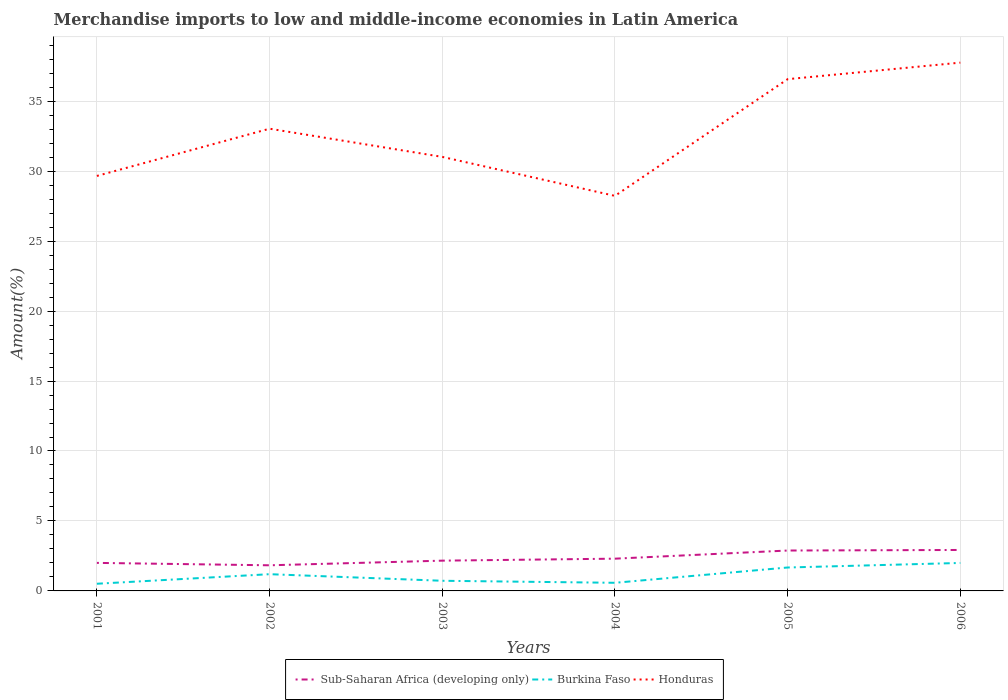Does the line corresponding to Sub-Saharan Africa (developing only) intersect with the line corresponding to Burkina Faso?
Make the answer very short. No. Is the number of lines equal to the number of legend labels?
Offer a very short reply. Yes. Across all years, what is the maximum percentage of amount earned from merchandise imports in Honduras?
Ensure brevity in your answer.  28.23. In which year was the percentage of amount earned from merchandise imports in Honduras maximum?
Your answer should be compact. 2004. What is the total percentage of amount earned from merchandise imports in Burkina Faso in the graph?
Provide a succinct answer. -0.07. What is the difference between the highest and the second highest percentage of amount earned from merchandise imports in Burkina Faso?
Offer a very short reply. 1.49. Is the percentage of amount earned from merchandise imports in Burkina Faso strictly greater than the percentage of amount earned from merchandise imports in Sub-Saharan Africa (developing only) over the years?
Give a very brief answer. Yes. How many lines are there?
Provide a succinct answer. 3. How many years are there in the graph?
Your response must be concise. 6. Are the values on the major ticks of Y-axis written in scientific E-notation?
Your response must be concise. No. Does the graph contain grids?
Provide a short and direct response. Yes. Where does the legend appear in the graph?
Provide a succinct answer. Bottom center. What is the title of the graph?
Provide a short and direct response. Merchandise imports to low and middle-income economies in Latin America. Does "St. Kitts and Nevis" appear as one of the legend labels in the graph?
Your answer should be very brief. No. What is the label or title of the Y-axis?
Keep it short and to the point. Amount(%). What is the Amount(%) in Sub-Saharan Africa (developing only) in 2001?
Provide a succinct answer. 2. What is the Amount(%) in Burkina Faso in 2001?
Offer a very short reply. 0.51. What is the Amount(%) in Honduras in 2001?
Keep it short and to the point. 29.66. What is the Amount(%) in Sub-Saharan Africa (developing only) in 2002?
Offer a very short reply. 1.83. What is the Amount(%) of Burkina Faso in 2002?
Your answer should be very brief. 1.2. What is the Amount(%) of Honduras in 2002?
Provide a short and direct response. 33.03. What is the Amount(%) in Sub-Saharan Africa (developing only) in 2003?
Your answer should be compact. 2.16. What is the Amount(%) in Burkina Faso in 2003?
Ensure brevity in your answer.  0.73. What is the Amount(%) of Honduras in 2003?
Your response must be concise. 31.02. What is the Amount(%) in Sub-Saharan Africa (developing only) in 2004?
Ensure brevity in your answer.  2.31. What is the Amount(%) of Burkina Faso in 2004?
Ensure brevity in your answer.  0.58. What is the Amount(%) of Honduras in 2004?
Your answer should be very brief. 28.23. What is the Amount(%) of Sub-Saharan Africa (developing only) in 2005?
Offer a terse response. 2.89. What is the Amount(%) in Burkina Faso in 2005?
Your answer should be very brief. 1.67. What is the Amount(%) in Honduras in 2005?
Your response must be concise. 36.57. What is the Amount(%) of Sub-Saharan Africa (developing only) in 2006?
Give a very brief answer. 2.93. What is the Amount(%) in Burkina Faso in 2006?
Your response must be concise. 2. What is the Amount(%) in Honduras in 2006?
Your answer should be compact. 37.76. Across all years, what is the maximum Amount(%) of Sub-Saharan Africa (developing only)?
Provide a succinct answer. 2.93. Across all years, what is the maximum Amount(%) in Burkina Faso?
Provide a succinct answer. 2. Across all years, what is the maximum Amount(%) in Honduras?
Your answer should be very brief. 37.76. Across all years, what is the minimum Amount(%) of Sub-Saharan Africa (developing only)?
Your answer should be very brief. 1.83. Across all years, what is the minimum Amount(%) in Burkina Faso?
Ensure brevity in your answer.  0.51. Across all years, what is the minimum Amount(%) in Honduras?
Your answer should be very brief. 28.23. What is the total Amount(%) in Sub-Saharan Africa (developing only) in the graph?
Your answer should be compact. 14.12. What is the total Amount(%) of Burkina Faso in the graph?
Keep it short and to the point. 6.69. What is the total Amount(%) of Honduras in the graph?
Your answer should be compact. 196.27. What is the difference between the Amount(%) of Sub-Saharan Africa (developing only) in 2001 and that in 2002?
Provide a short and direct response. 0.17. What is the difference between the Amount(%) in Burkina Faso in 2001 and that in 2002?
Your response must be concise. -0.68. What is the difference between the Amount(%) of Honduras in 2001 and that in 2002?
Make the answer very short. -3.38. What is the difference between the Amount(%) of Sub-Saharan Africa (developing only) in 2001 and that in 2003?
Keep it short and to the point. -0.16. What is the difference between the Amount(%) in Burkina Faso in 2001 and that in 2003?
Offer a very short reply. -0.21. What is the difference between the Amount(%) of Honduras in 2001 and that in 2003?
Your response must be concise. -1.36. What is the difference between the Amount(%) of Sub-Saharan Africa (developing only) in 2001 and that in 2004?
Offer a very short reply. -0.3. What is the difference between the Amount(%) in Burkina Faso in 2001 and that in 2004?
Offer a terse response. -0.07. What is the difference between the Amount(%) of Honduras in 2001 and that in 2004?
Offer a very short reply. 1.42. What is the difference between the Amount(%) of Sub-Saharan Africa (developing only) in 2001 and that in 2005?
Provide a short and direct response. -0.88. What is the difference between the Amount(%) of Burkina Faso in 2001 and that in 2005?
Offer a terse response. -1.16. What is the difference between the Amount(%) in Honduras in 2001 and that in 2005?
Ensure brevity in your answer.  -6.92. What is the difference between the Amount(%) in Sub-Saharan Africa (developing only) in 2001 and that in 2006?
Provide a succinct answer. -0.92. What is the difference between the Amount(%) of Burkina Faso in 2001 and that in 2006?
Your response must be concise. -1.49. What is the difference between the Amount(%) of Honduras in 2001 and that in 2006?
Offer a very short reply. -8.1. What is the difference between the Amount(%) in Sub-Saharan Africa (developing only) in 2002 and that in 2003?
Your answer should be very brief. -0.33. What is the difference between the Amount(%) in Burkina Faso in 2002 and that in 2003?
Your answer should be compact. 0.47. What is the difference between the Amount(%) of Honduras in 2002 and that in 2003?
Provide a succinct answer. 2.01. What is the difference between the Amount(%) of Sub-Saharan Africa (developing only) in 2002 and that in 2004?
Ensure brevity in your answer.  -0.47. What is the difference between the Amount(%) in Burkina Faso in 2002 and that in 2004?
Your answer should be compact. 0.62. What is the difference between the Amount(%) in Honduras in 2002 and that in 2004?
Make the answer very short. 4.8. What is the difference between the Amount(%) of Sub-Saharan Africa (developing only) in 2002 and that in 2005?
Provide a succinct answer. -1.06. What is the difference between the Amount(%) of Burkina Faso in 2002 and that in 2005?
Ensure brevity in your answer.  -0.48. What is the difference between the Amount(%) in Honduras in 2002 and that in 2005?
Provide a short and direct response. -3.54. What is the difference between the Amount(%) in Sub-Saharan Africa (developing only) in 2002 and that in 2006?
Offer a terse response. -1.1. What is the difference between the Amount(%) of Burkina Faso in 2002 and that in 2006?
Keep it short and to the point. -0.8. What is the difference between the Amount(%) of Honduras in 2002 and that in 2006?
Provide a short and direct response. -4.72. What is the difference between the Amount(%) of Sub-Saharan Africa (developing only) in 2003 and that in 2004?
Ensure brevity in your answer.  -0.14. What is the difference between the Amount(%) in Burkina Faso in 2003 and that in 2004?
Give a very brief answer. 0.14. What is the difference between the Amount(%) in Honduras in 2003 and that in 2004?
Provide a short and direct response. 2.79. What is the difference between the Amount(%) in Sub-Saharan Africa (developing only) in 2003 and that in 2005?
Offer a very short reply. -0.72. What is the difference between the Amount(%) in Burkina Faso in 2003 and that in 2005?
Give a very brief answer. -0.95. What is the difference between the Amount(%) of Honduras in 2003 and that in 2005?
Offer a very short reply. -5.55. What is the difference between the Amount(%) in Sub-Saharan Africa (developing only) in 2003 and that in 2006?
Your answer should be very brief. -0.76. What is the difference between the Amount(%) in Burkina Faso in 2003 and that in 2006?
Your response must be concise. -1.27. What is the difference between the Amount(%) of Honduras in 2003 and that in 2006?
Your response must be concise. -6.74. What is the difference between the Amount(%) of Sub-Saharan Africa (developing only) in 2004 and that in 2005?
Offer a terse response. -0.58. What is the difference between the Amount(%) of Burkina Faso in 2004 and that in 2005?
Provide a short and direct response. -1.09. What is the difference between the Amount(%) in Honduras in 2004 and that in 2005?
Offer a very short reply. -8.34. What is the difference between the Amount(%) in Sub-Saharan Africa (developing only) in 2004 and that in 2006?
Keep it short and to the point. -0.62. What is the difference between the Amount(%) of Burkina Faso in 2004 and that in 2006?
Provide a succinct answer. -1.42. What is the difference between the Amount(%) of Honduras in 2004 and that in 2006?
Your answer should be very brief. -9.52. What is the difference between the Amount(%) in Sub-Saharan Africa (developing only) in 2005 and that in 2006?
Your answer should be compact. -0.04. What is the difference between the Amount(%) of Burkina Faso in 2005 and that in 2006?
Offer a terse response. -0.32. What is the difference between the Amount(%) of Honduras in 2005 and that in 2006?
Ensure brevity in your answer.  -1.18. What is the difference between the Amount(%) in Sub-Saharan Africa (developing only) in 2001 and the Amount(%) in Burkina Faso in 2002?
Give a very brief answer. 0.81. What is the difference between the Amount(%) in Sub-Saharan Africa (developing only) in 2001 and the Amount(%) in Honduras in 2002?
Your answer should be very brief. -31.03. What is the difference between the Amount(%) in Burkina Faso in 2001 and the Amount(%) in Honduras in 2002?
Make the answer very short. -32.52. What is the difference between the Amount(%) of Sub-Saharan Africa (developing only) in 2001 and the Amount(%) of Burkina Faso in 2003?
Give a very brief answer. 1.28. What is the difference between the Amount(%) of Sub-Saharan Africa (developing only) in 2001 and the Amount(%) of Honduras in 2003?
Offer a terse response. -29.02. What is the difference between the Amount(%) in Burkina Faso in 2001 and the Amount(%) in Honduras in 2003?
Your response must be concise. -30.51. What is the difference between the Amount(%) of Sub-Saharan Africa (developing only) in 2001 and the Amount(%) of Burkina Faso in 2004?
Keep it short and to the point. 1.42. What is the difference between the Amount(%) in Sub-Saharan Africa (developing only) in 2001 and the Amount(%) in Honduras in 2004?
Provide a short and direct response. -26.23. What is the difference between the Amount(%) in Burkina Faso in 2001 and the Amount(%) in Honduras in 2004?
Keep it short and to the point. -27.72. What is the difference between the Amount(%) in Sub-Saharan Africa (developing only) in 2001 and the Amount(%) in Burkina Faso in 2005?
Offer a very short reply. 0.33. What is the difference between the Amount(%) in Sub-Saharan Africa (developing only) in 2001 and the Amount(%) in Honduras in 2005?
Ensure brevity in your answer.  -34.57. What is the difference between the Amount(%) in Burkina Faso in 2001 and the Amount(%) in Honduras in 2005?
Offer a very short reply. -36.06. What is the difference between the Amount(%) of Sub-Saharan Africa (developing only) in 2001 and the Amount(%) of Burkina Faso in 2006?
Your response must be concise. 0.01. What is the difference between the Amount(%) of Sub-Saharan Africa (developing only) in 2001 and the Amount(%) of Honduras in 2006?
Offer a very short reply. -35.75. What is the difference between the Amount(%) of Burkina Faso in 2001 and the Amount(%) of Honduras in 2006?
Give a very brief answer. -37.24. What is the difference between the Amount(%) of Sub-Saharan Africa (developing only) in 2002 and the Amount(%) of Burkina Faso in 2003?
Provide a short and direct response. 1.11. What is the difference between the Amount(%) of Sub-Saharan Africa (developing only) in 2002 and the Amount(%) of Honduras in 2003?
Your answer should be very brief. -29.19. What is the difference between the Amount(%) of Burkina Faso in 2002 and the Amount(%) of Honduras in 2003?
Your response must be concise. -29.82. What is the difference between the Amount(%) of Sub-Saharan Africa (developing only) in 2002 and the Amount(%) of Burkina Faso in 2004?
Your response must be concise. 1.25. What is the difference between the Amount(%) in Sub-Saharan Africa (developing only) in 2002 and the Amount(%) in Honduras in 2004?
Your answer should be very brief. -26.4. What is the difference between the Amount(%) in Burkina Faso in 2002 and the Amount(%) in Honduras in 2004?
Give a very brief answer. -27.04. What is the difference between the Amount(%) in Sub-Saharan Africa (developing only) in 2002 and the Amount(%) in Burkina Faso in 2005?
Provide a short and direct response. 0.16. What is the difference between the Amount(%) of Sub-Saharan Africa (developing only) in 2002 and the Amount(%) of Honduras in 2005?
Keep it short and to the point. -34.74. What is the difference between the Amount(%) in Burkina Faso in 2002 and the Amount(%) in Honduras in 2005?
Keep it short and to the point. -35.38. What is the difference between the Amount(%) of Sub-Saharan Africa (developing only) in 2002 and the Amount(%) of Burkina Faso in 2006?
Offer a very short reply. -0.17. What is the difference between the Amount(%) of Sub-Saharan Africa (developing only) in 2002 and the Amount(%) of Honduras in 2006?
Provide a short and direct response. -35.92. What is the difference between the Amount(%) of Burkina Faso in 2002 and the Amount(%) of Honduras in 2006?
Your response must be concise. -36.56. What is the difference between the Amount(%) of Sub-Saharan Africa (developing only) in 2003 and the Amount(%) of Burkina Faso in 2004?
Your answer should be very brief. 1.58. What is the difference between the Amount(%) in Sub-Saharan Africa (developing only) in 2003 and the Amount(%) in Honduras in 2004?
Your response must be concise. -26.07. What is the difference between the Amount(%) of Burkina Faso in 2003 and the Amount(%) of Honduras in 2004?
Ensure brevity in your answer.  -27.51. What is the difference between the Amount(%) in Sub-Saharan Africa (developing only) in 2003 and the Amount(%) in Burkina Faso in 2005?
Your answer should be very brief. 0.49. What is the difference between the Amount(%) of Sub-Saharan Africa (developing only) in 2003 and the Amount(%) of Honduras in 2005?
Your response must be concise. -34.41. What is the difference between the Amount(%) of Burkina Faso in 2003 and the Amount(%) of Honduras in 2005?
Keep it short and to the point. -35.85. What is the difference between the Amount(%) in Sub-Saharan Africa (developing only) in 2003 and the Amount(%) in Burkina Faso in 2006?
Provide a short and direct response. 0.16. What is the difference between the Amount(%) of Sub-Saharan Africa (developing only) in 2003 and the Amount(%) of Honduras in 2006?
Give a very brief answer. -35.59. What is the difference between the Amount(%) of Burkina Faso in 2003 and the Amount(%) of Honduras in 2006?
Provide a short and direct response. -37.03. What is the difference between the Amount(%) of Sub-Saharan Africa (developing only) in 2004 and the Amount(%) of Burkina Faso in 2005?
Your response must be concise. 0.63. What is the difference between the Amount(%) of Sub-Saharan Africa (developing only) in 2004 and the Amount(%) of Honduras in 2005?
Give a very brief answer. -34.27. What is the difference between the Amount(%) in Burkina Faso in 2004 and the Amount(%) in Honduras in 2005?
Keep it short and to the point. -35.99. What is the difference between the Amount(%) of Sub-Saharan Africa (developing only) in 2004 and the Amount(%) of Burkina Faso in 2006?
Offer a very short reply. 0.31. What is the difference between the Amount(%) of Sub-Saharan Africa (developing only) in 2004 and the Amount(%) of Honduras in 2006?
Offer a terse response. -35.45. What is the difference between the Amount(%) of Burkina Faso in 2004 and the Amount(%) of Honduras in 2006?
Keep it short and to the point. -37.17. What is the difference between the Amount(%) in Sub-Saharan Africa (developing only) in 2005 and the Amount(%) in Burkina Faso in 2006?
Provide a succinct answer. 0.89. What is the difference between the Amount(%) of Sub-Saharan Africa (developing only) in 2005 and the Amount(%) of Honduras in 2006?
Make the answer very short. -34.87. What is the difference between the Amount(%) in Burkina Faso in 2005 and the Amount(%) in Honduras in 2006?
Offer a terse response. -36.08. What is the average Amount(%) in Sub-Saharan Africa (developing only) per year?
Your answer should be very brief. 2.35. What is the average Amount(%) in Burkina Faso per year?
Your response must be concise. 1.11. What is the average Amount(%) in Honduras per year?
Keep it short and to the point. 32.71. In the year 2001, what is the difference between the Amount(%) in Sub-Saharan Africa (developing only) and Amount(%) in Burkina Faso?
Provide a succinct answer. 1.49. In the year 2001, what is the difference between the Amount(%) of Sub-Saharan Africa (developing only) and Amount(%) of Honduras?
Provide a short and direct response. -27.65. In the year 2001, what is the difference between the Amount(%) of Burkina Faso and Amount(%) of Honduras?
Give a very brief answer. -29.14. In the year 2002, what is the difference between the Amount(%) of Sub-Saharan Africa (developing only) and Amount(%) of Burkina Faso?
Your answer should be very brief. 0.64. In the year 2002, what is the difference between the Amount(%) of Sub-Saharan Africa (developing only) and Amount(%) of Honduras?
Your answer should be very brief. -31.2. In the year 2002, what is the difference between the Amount(%) of Burkina Faso and Amount(%) of Honduras?
Your answer should be very brief. -31.84. In the year 2003, what is the difference between the Amount(%) in Sub-Saharan Africa (developing only) and Amount(%) in Burkina Faso?
Provide a short and direct response. 1.44. In the year 2003, what is the difference between the Amount(%) in Sub-Saharan Africa (developing only) and Amount(%) in Honduras?
Offer a very short reply. -28.86. In the year 2003, what is the difference between the Amount(%) of Burkina Faso and Amount(%) of Honduras?
Ensure brevity in your answer.  -30.29. In the year 2004, what is the difference between the Amount(%) of Sub-Saharan Africa (developing only) and Amount(%) of Burkina Faso?
Give a very brief answer. 1.72. In the year 2004, what is the difference between the Amount(%) of Sub-Saharan Africa (developing only) and Amount(%) of Honduras?
Offer a very short reply. -25.93. In the year 2004, what is the difference between the Amount(%) of Burkina Faso and Amount(%) of Honduras?
Your response must be concise. -27.65. In the year 2005, what is the difference between the Amount(%) in Sub-Saharan Africa (developing only) and Amount(%) in Burkina Faso?
Your response must be concise. 1.21. In the year 2005, what is the difference between the Amount(%) of Sub-Saharan Africa (developing only) and Amount(%) of Honduras?
Give a very brief answer. -33.69. In the year 2005, what is the difference between the Amount(%) of Burkina Faso and Amount(%) of Honduras?
Your answer should be compact. -34.9. In the year 2006, what is the difference between the Amount(%) in Sub-Saharan Africa (developing only) and Amount(%) in Burkina Faso?
Offer a very short reply. 0.93. In the year 2006, what is the difference between the Amount(%) of Sub-Saharan Africa (developing only) and Amount(%) of Honduras?
Offer a very short reply. -34.83. In the year 2006, what is the difference between the Amount(%) in Burkina Faso and Amount(%) in Honduras?
Make the answer very short. -35.76. What is the ratio of the Amount(%) in Sub-Saharan Africa (developing only) in 2001 to that in 2002?
Offer a very short reply. 1.09. What is the ratio of the Amount(%) in Burkina Faso in 2001 to that in 2002?
Ensure brevity in your answer.  0.43. What is the ratio of the Amount(%) in Honduras in 2001 to that in 2002?
Your response must be concise. 0.9. What is the ratio of the Amount(%) of Sub-Saharan Africa (developing only) in 2001 to that in 2003?
Your response must be concise. 0.93. What is the ratio of the Amount(%) in Burkina Faso in 2001 to that in 2003?
Keep it short and to the point. 0.71. What is the ratio of the Amount(%) in Honduras in 2001 to that in 2003?
Make the answer very short. 0.96. What is the ratio of the Amount(%) in Sub-Saharan Africa (developing only) in 2001 to that in 2004?
Give a very brief answer. 0.87. What is the ratio of the Amount(%) of Burkina Faso in 2001 to that in 2004?
Give a very brief answer. 0.88. What is the ratio of the Amount(%) of Honduras in 2001 to that in 2004?
Your answer should be compact. 1.05. What is the ratio of the Amount(%) in Sub-Saharan Africa (developing only) in 2001 to that in 2005?
Provide a succinct answer. 0.69. What is the ratio of the Amount(%) of Burkina Faso in 2001 to that in 2005?
Give a very brief answer. 0.31. What is the ratio of the Amount(%) in Honduras in 2001 to that in 2005?
Make the answer very short. 0.81. What is the ratio of the Amount(%) of Sub-Saharan Africa (developing only) in 2001 to that in 2006?
Keep it short and to the point. 0.68. What is the ratio of the Amount(%) in Burkina Faso in 2001 to that in 2006?
Your answer should be compact. 0.26. What is the ratio of the Amount(%) of Honduras in 2001 to that in 2006?
Give a very brief answer. 0.79. What is the ratio of the Amount(%) of Sub-Saharan Africa (developing only) in 2002 to that in 2003?
Offer a terse response. 0.85. What is the ratio of the Amount(%) in Burkina Faso in 2002 to that in 2003?
Your answer should be very brief. 1.65. What is the ratio of the Amount(%) in Honduras in 2002 to that in 2003?
Provide a short and direct response. 1.06. What is the ratio of the Amount(%) in Sub-Saharan Africa (developing only) in 2002 to that in 2004?
Your answer should be compact. 0.79. What is the ratio of the Amount(%) of Burkina Faso in 2002 to that in 2004?
Your response must be concise. 2.06. What is the ratio of the Amount(%) in Honduras in 2002 to that in 2004?
Keep it short and to the point. 1.17. What is the ratio of the Amount(%) of Sub-Saharan Africa (developing only) in 2002 to that in 2005?
Give a very brief answer. 0.63. What is the ratio of the Amount(%) in Burkina Faso in 2002 to that in 2005?
Offer a very short reply. 0.71. What is the ratio of the Amount(%) of Honduras in 2002 to that in 2005?
Give a very brief answer. 0.9. What is the ratio of the Amount(%) of Sub-Saharan Africa (developing only) in 2002 to that in 2006?
Your response must be concise. 0.63. What is the ratio of the Amount(%) in Burkina Faso in 2002 to that in 2006?
Give a very brief answer. 0.6. What is the ratio of the Amount(%) in Honduras in 2002 to that in 2006?
Provide a short and direct response. 0.87. What is the ratio of the Amount(%) in Sub-Saharan Africa (developing only) in 2003 to that in 2004?
Give a very brief answer. 0.94. What is the ratio of the Amount(%) in Burkina Faso in 2003 to that in 2004?
Your answer should be very brief. 1.25. What is the ratio of the Amount(%) of Honduras in 2003 to that in 2004?
Ensure brevity in your answer.  1.1. What is the ratio of the Amount(%) of Sub-Saharan Africa (developing only) in 2003 to that in 2005?
Offer a very short reply. 0.75. What is the ratio of the Amount(%) of Burkina Faso in 2003 to that in 2005?
Your answer should be very brief. 0.43. What is the ratio of the Amount(%) in Honduras in 2003 to that in 2005?
Give a very brief answer. 0.85. What is the ratio of the Amount(%) of Sub-Saharan Africa (developing only) in 2003 to that in 2006?
Offer a terse response. 0.74. What is the ratio of the Amount(%) in Burkina Faso in 2003 to that in 2006?
Give a very brief answer. 0.36. What is the ratio of the Amount(%) of Honduras in 2003 to that in 2006?
Your answer should be compact. 0.82. What is the ratio of the Amount(%) in Sub-Saharan Africa (developing only) in 2004 to that in 2005?
Your answer should be very brief. 0.8. What is the ratio of the Amount(%) in Burkina Faso in 2004 to that in 2005?
Ensure brevity in your answer.  0.35. What is the ratio of the Amount(%) of Honduras in 2004 to that in 2005?
Offer a very short reply. 0.77. What is the ratio of the Amount(%) in Sub-Saharan Africa (developing only) in 2004 to that in 2006?
Keep it short and to the point. 0.79. What is the ratio of the Amount(%) in Burkina Faso in 2004 to that in 2006?
Your answer should be compact. 0.29. What is the ratio of the Amount(%) in Honduras in 2004 to that in 2006?
Provide a short and direct response. 0.75. What is the ratio of the Amount(%) of Sub-Saharan Africa (developing only) in 2005 to that in 2006?
Provide a succinct answer. 0.99. What is the ratio of the Amount(%) of Burkina Faso in 2005 to that in 2006?
Keep it short and to the point. 0.84. What is the ratio of the Amount(%) in Honduras in 2005 to that in 2006?
Provide a succinct answer. 0.97. What is the difference between the highest and the second highest Amount(%) in Sub-Saharan Africa (developing only)?
Your response must be concise. 0.04. What is the difference between the highest and the second highest Amount(%) of Burkina Faso?
Make the answer very short. 0.32. What is the difference between the highest and the second highest Amount(%) in Honduras?
Offer a terse response. 1.18. What is the difference between the highest and the lowest Amount(%) in Sub-Saharan Africa (developing only)?
Provide a succinct answer. 1.1. What is the difference between the highest and the lowest Amount(%) in Burkina Faso?
Your answer should be compact. 1.49. What is the difference between the highest and the lowest Amount(%) of Honduras?
Offer a very short reply. 9.52. 